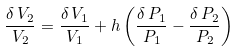Convert formula to latex. <formula><loc_0><loc_0><loc_500><loc_500>\frac { \delta \, V _ { 2 } } { V _ { 2 } } = \frac { \delta \, V _ { 1 } } { V _ { 1 } } + h \left ( \frac { \delta \, P _ { 1 } } { P _ { 1 } } - \frac { \delta \, P _ { 2 } } { P _ { 2 } } \right )</formula> 